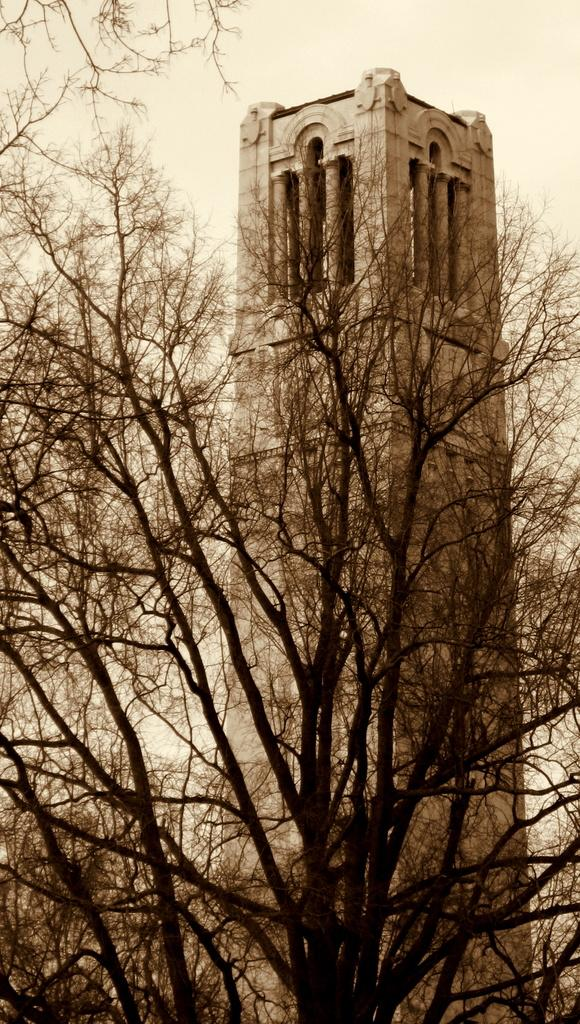What type of vegetation can be seen in the image? There are trees in the image. What structure is visible in the background of the image? There is a tower in the background of the image. Can you see any fish swimming in the image? There are no fish present in the image; it features trees and a tower. What type of trade is being conducted in the image? There is no trade activity depicted in the image; it only shows trees and a tower. 